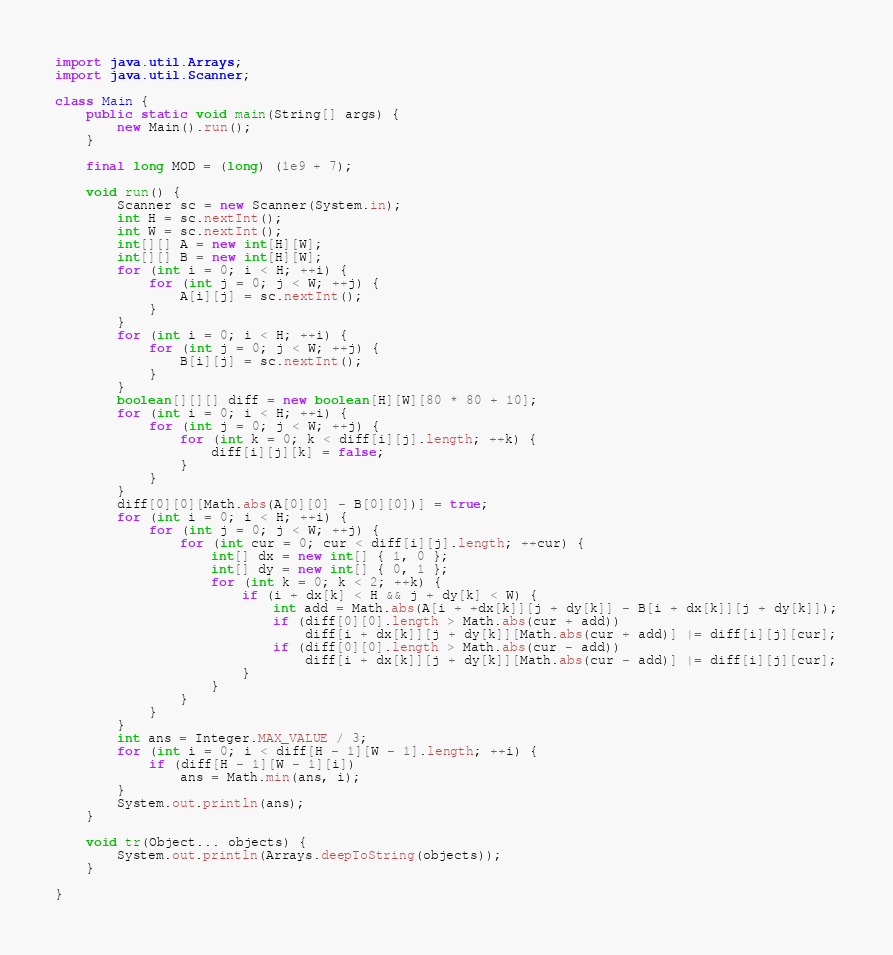<code> <loc_0><loc_0><loc_500><loc_500><_Java_>
import java.util.Arrays;
import java.util.Scanner;

class Main {
	public static void main(String[] args) {
		new Main().run();
	}

	final long MOD = (long) (1e9 + 7);

	void run() {
		Scanner sc = new Scanner(System.in);
		int H = sc.nextInt();
		int W = sc.nextInt();
		int[][] A = new int[H][W];
		int[][] B = new int[H][W];
		for (int i = 0; i < H; ++i) {
			for (int j = 0; j < W; ++j) {
				A[i][j] = sc.nextInt();
			}
		}
		for (int i = 0; i < H; ++i) {
			for (int j = 0; j < W; ++j) {
				B[i][j] = sc.nextInt();
			}
		}
		boolean[][][] diff = new boolean[H][W][80 * 80 + 10];
		for (int i = 0; i < H; ++i) {
			for (int j = 0; j < W; ++j) {
				for (int k = 0; k < diff[i][j].length; ++k) {
					diff[i][j][k] = false;
				}
			}
		}
		diff[0][0][Math.abs(A[0][0] - B[0][0])] = true;
		for (int i = 0; i < H; ++i) {
			for (int j = 0; j < W; ++j) {
				for (int cur = 0; cur < diff[i][j].length; ++cur) {
					int[] dx = new int[] { 1, 0 };
					int[] dy = new int[] { 0, 1 };
					for (int k = 0; k < 2; ++k) {
						if (i + dx[k] < H && j + dy[k] < W) {
							int add = Math.abs(A[i + +dx[k]][j + dy[k]] - B[i + dx[k]][j + dy[k]]);
							if (diff[0][0].length > Math.abs(cur + add))
								diff[i + dx[k]][j + dy[k]][Math.abs(cur + add)] |= diff[i][j][cur];
							if (diff[0][0].length > Math.abs(cur - add))
								diff[i + dx[k]][j + dy[k]][Math.abs(cur - add)] |= diff[i][j][cur];
						}
					}
				}
			}
		}
		int ans = Integer.MAX_VALUE / 3;
		for (int i = 0; i < diff[H - 1][W - 1].length; ++i) {
			if (diff[H - 1][W - 1][i])
				ans = Math.min(ans, i);
		}
		System.out.println(ans);
	}

	void tr(Object... objects) {
		System.out.println(Arrays.deepToString(objects));
	}

}
</code> 